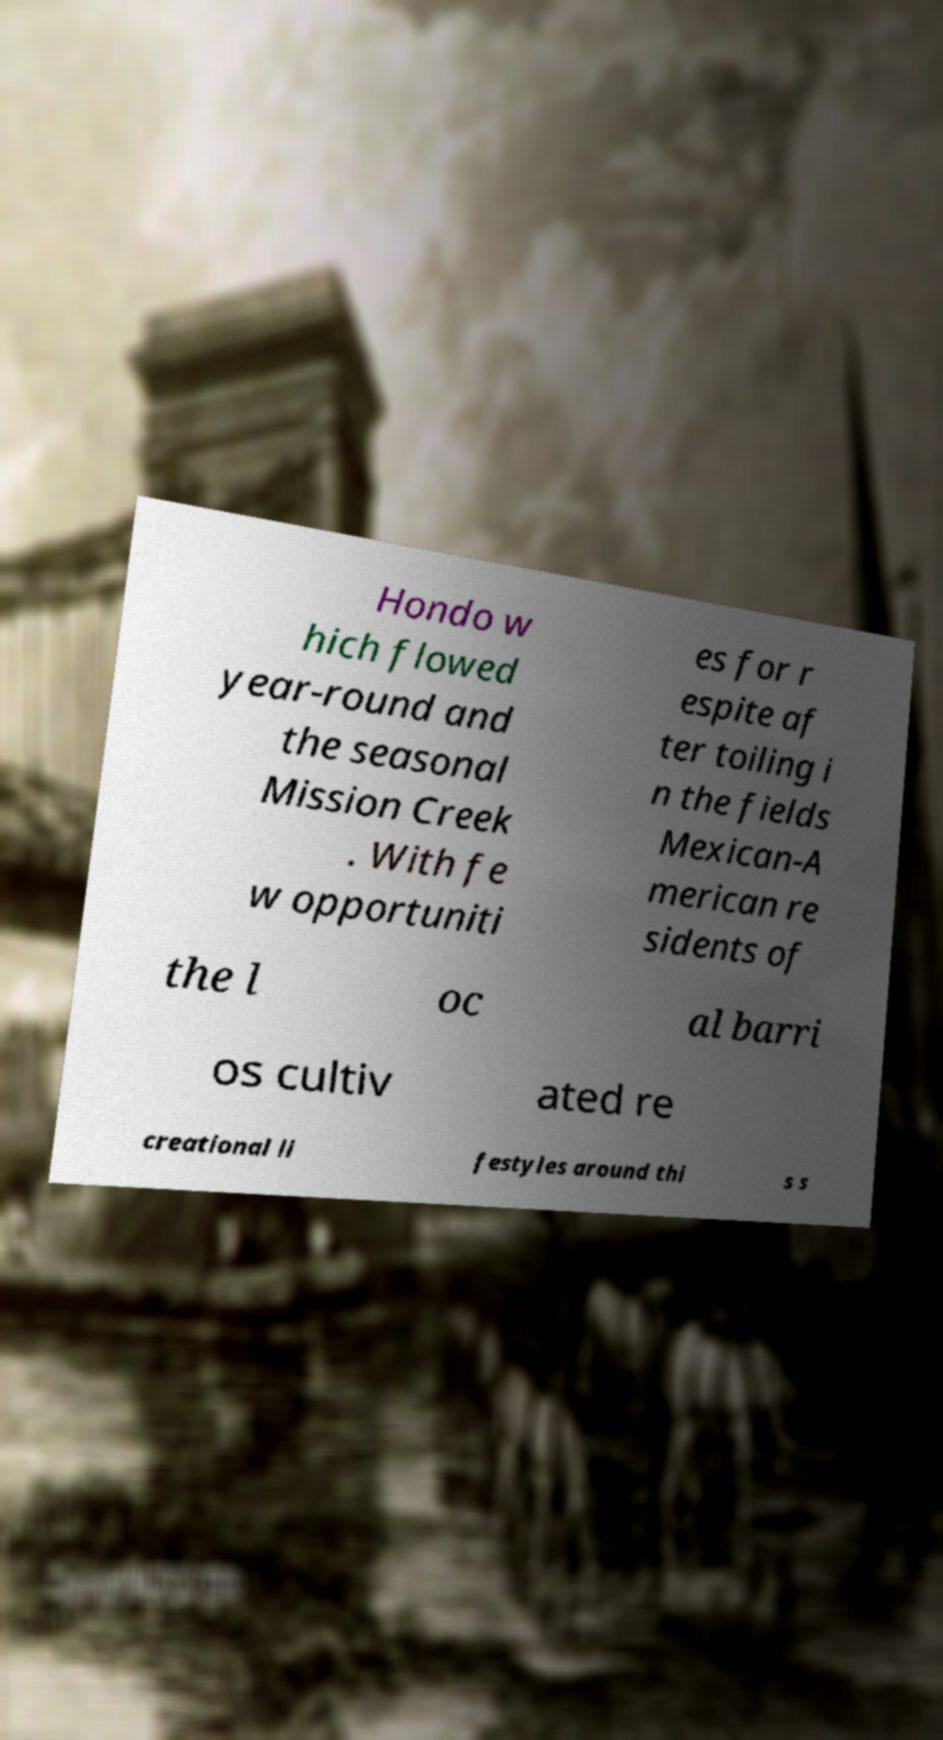Could you assist in decoding the text presented in this image and type it out clearly? Hondo w hich flowed year-round and the seasonal Mission Creek . With fe w opportuniti es for r espite af ter toiling i n the fields Mexican-A merican re sidents of the l oc al barri os cultiv ated re creational li festyles around thi s s 